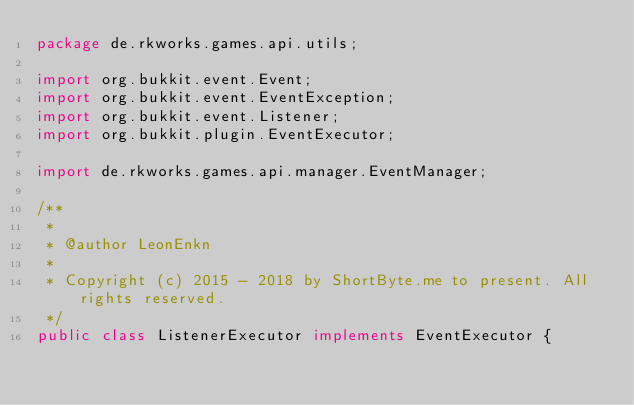Convert code to text. <code><loc_0><loc_0><loc_500><loc_500><_Java_>package de.rkworks.games.api.utils;

import org.bukkit.event.Event;
import org.bukkit.event.EventException;
import org.bukkit.event.Listener;
import org.bukkit.plugin.EventExecutor;

import de.rkworks.games.api.manager.EventManager;

/**
 *
 * @author LeonEnkn
 *
 * Copyright (c) 2015 - 2018 by ShortByte.me to present. All rights reserved.
 */
public class ListenerExecutor implements EventExecutor {
</code> 